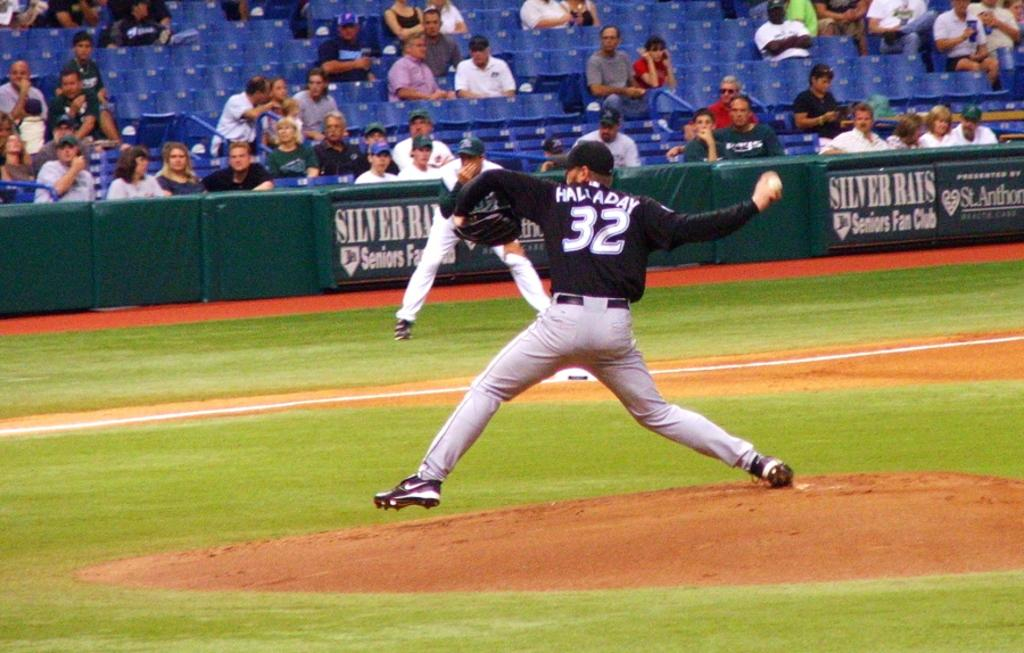Provide a one-sentence caption for the provided image. Hallady, the number 32 Baseball player throws the ball as an opponent watches on in front of advertising boards for Silver Ray Seniors Fan Club. 